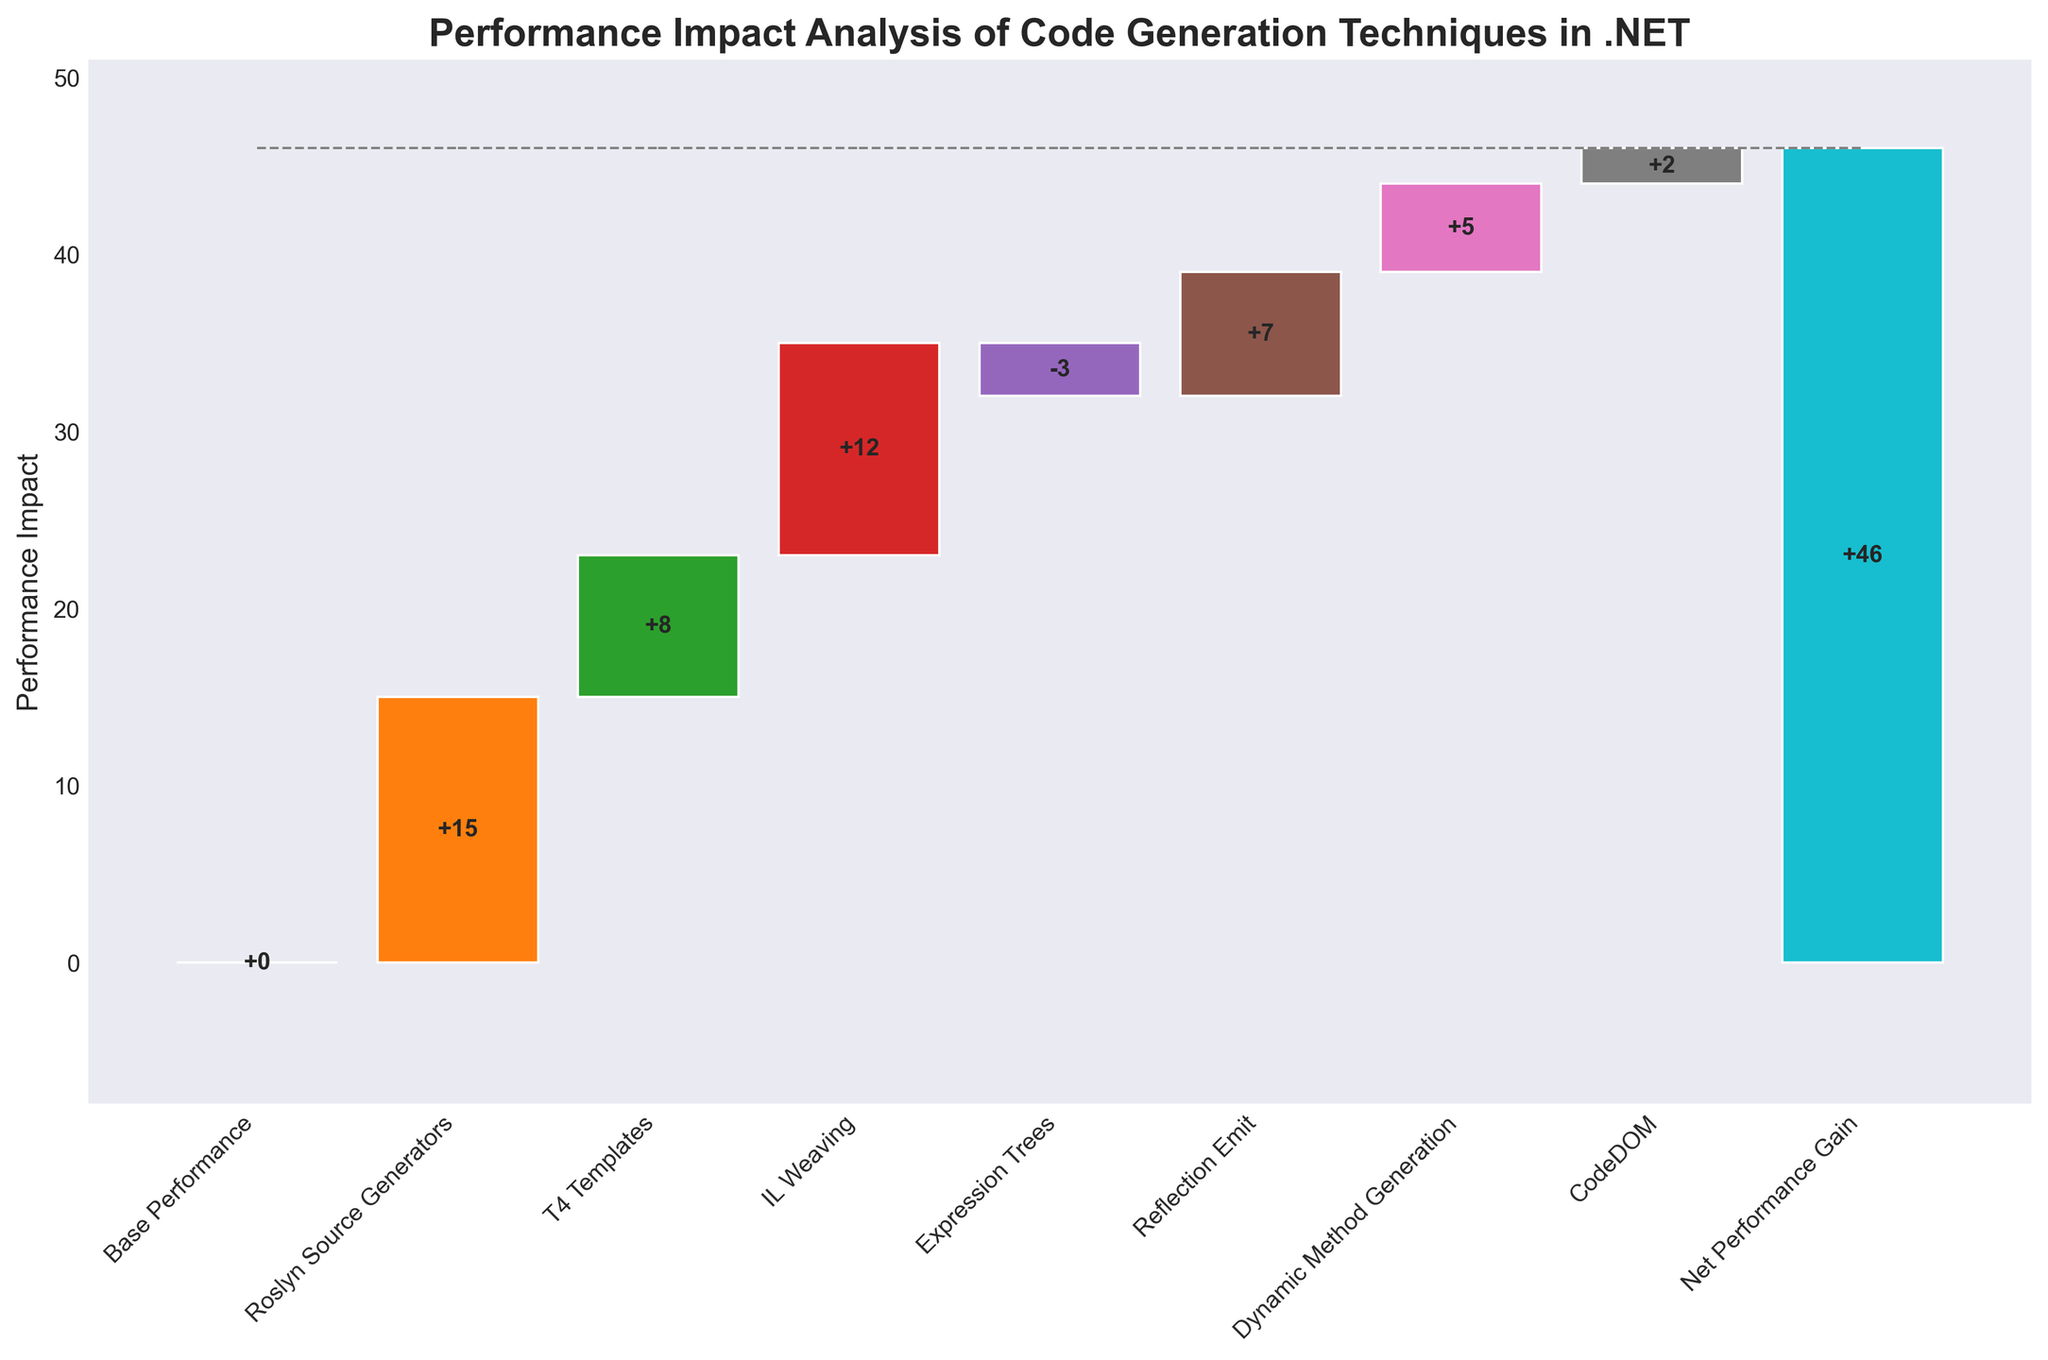What is the title of the chart? The title is usually located at the top of the chart. In this case, it reads "Performance Impact Analysis of Code Generation Techniques in .NET".
Answer: Performance Impact Analysis of Code Generation Techniques in .NET What is the highest performance gain among the different code generation techniques? To find the highest performance gain, look at the individual bars and identify the one with the highest value. Roslyn Source Generators has a value of 15, which is the highest.
Answer: Roslyn Source Generators What technique shows a negative impact on performance? A negative impact is shown by a bar going downward. In this case, Expression Trees shows a negative impact with a value of -3.
Answer: Expression Trees What is the total net performance gain? The Net Performance Gain is explicitly mentioned as a category in the chart with a value. According to the data, it is 46.
Answer: 46 Which code generation technique has the smallest positive performance impact? Among the positive values, CodeDOM has the smallest improvement with a value of 2.
Answer: CodeDOM What is the performance impact of IL Weaving? IL Weaving is explicitly labeled on the x-axis of the chart with a corresponding value. The value is 12.
Answer: 12 How does Reflection Emit's impact compare to T4 Templates? To compare, look at the values for Reflection Emit and T4 Templates. Reflection Emit has a value of 7, and T4 Templates has a value of 8. Reflection Emit has a slightly lesser impact compared to T4 Templates.
Answer: T4 Templates is higher by 1 What is the overall cumulative performance impact before considering the Net Performance Gain? Sum the impact values of all techniques except the Net Performance Gain. The values are 15 + 8 + 12 - 3 + 7 + 5 + 2, which equals 46.
Answer: 46 Which two techniques together contribute the most to the net performance gain? Assess the values of each technique and find the two highest. Roslyn Source Generators (15) and IL Weaving (12) are the highest contributors. Their sum is 27, which is the highest.
Answer: Roslyn Source Generators and IL Weaving How many techniques show an impact greater than 10? Count the number of techniques with values greater than 10. Only two techniques fit this criterion: Roslyn Source Generators (15) and IL Weaving (12).
Answer: 2 